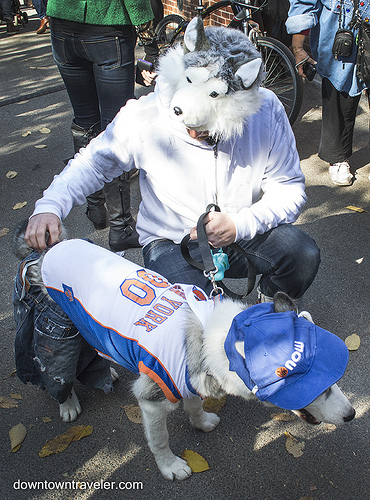<image>
Is there a camera on the man? No. The camera is not positioned on the man. They may be near each other, but the camera is not supported by or resting on top of the man. 